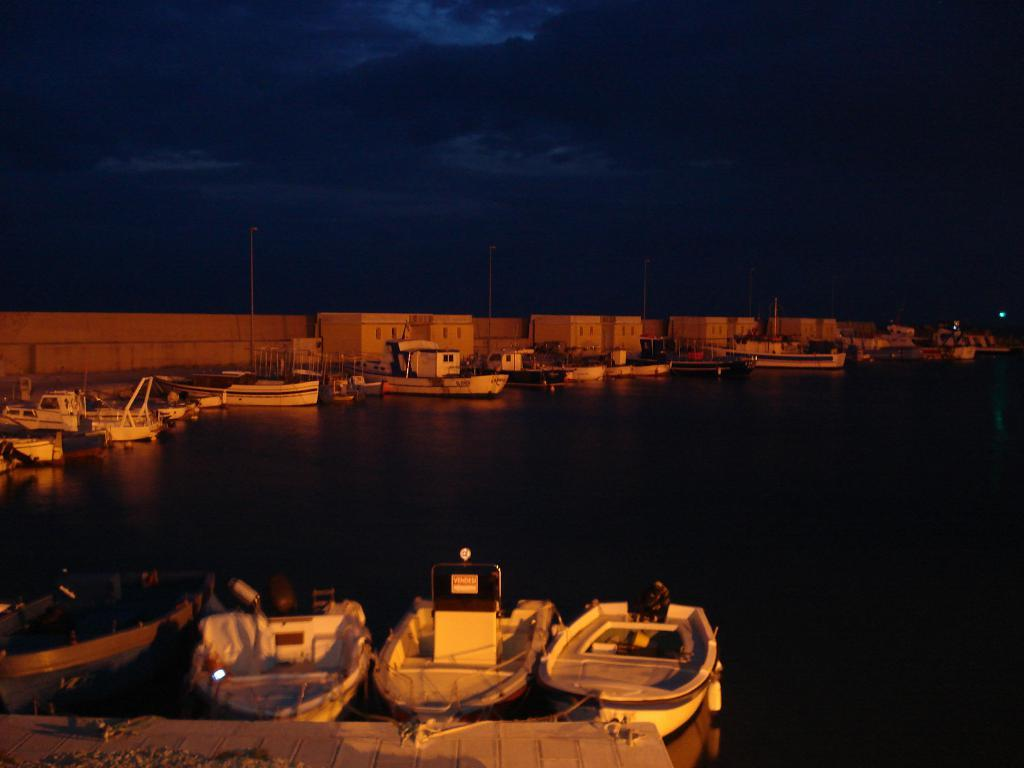What type of vehicles can be seen in the image? There are boats in the image. What is the position of the boats in the image? The boats are standing on the ground in the image. What can be seen in the distance behind the boats? There are buildings visible in the background of the image. What type of unit is responsible for maintaining the dock in the image? There is no dock present in the image, so it is not possible to determine which unit might be responsible for maintaining it. 